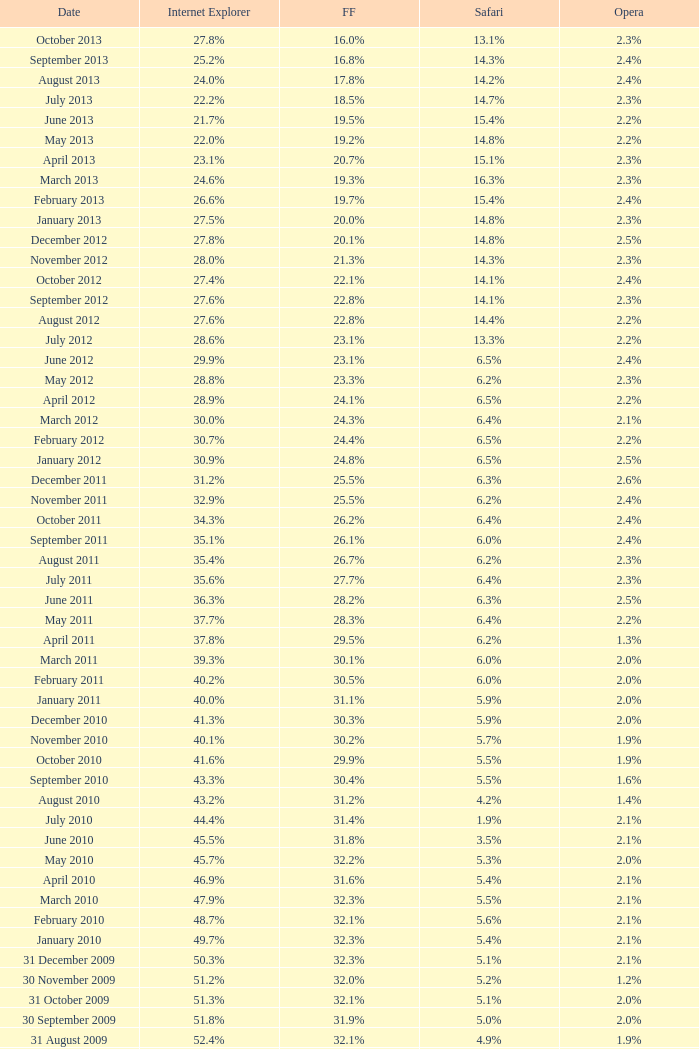What is the firefox value with a 1.9% safari? 31.4%. 